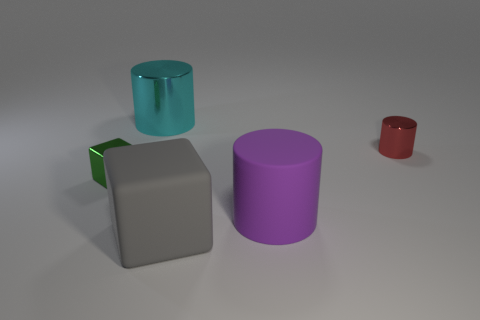What number of objects are small shiny things to the right of the big gray block or cyan things?
Make the answer very short. 2. Are there any other metallic objects of the same shape as the green metallic thing?
Keep it short and to the point. No. What shape is the other matte thing that is the same size as the purple object?
Ensure brevity in your answer.  Cube. What is the shape of the small object that is on the left side of the metallic cylinder that is right of the big block that is in front of the large metallic cylinder?
Make the answer very short. Cube. Is the shape of the small red metallic thing the same as the shiny object in front of the red metallic cylinder?
Provide a succinct answer. No. How many big objects are either brown things or purple things?
Your answer should be very brief. 1. Is there a cylinder that has the same size as the cyan metal thing?
Offer a very short reply. Yes. There is a metal thing in front of the small object that is behind the object that is left of the large cyan cylinder; what is its color?
Make the answer very short. Green. Is the material of the big cube the same as the large cylinder that is behind the large purple cylinder?
Keep it short and to the point. No. The rubber thing that is the same shape as the tiny red shiny object is what size?
Make the answer very short. Large. 